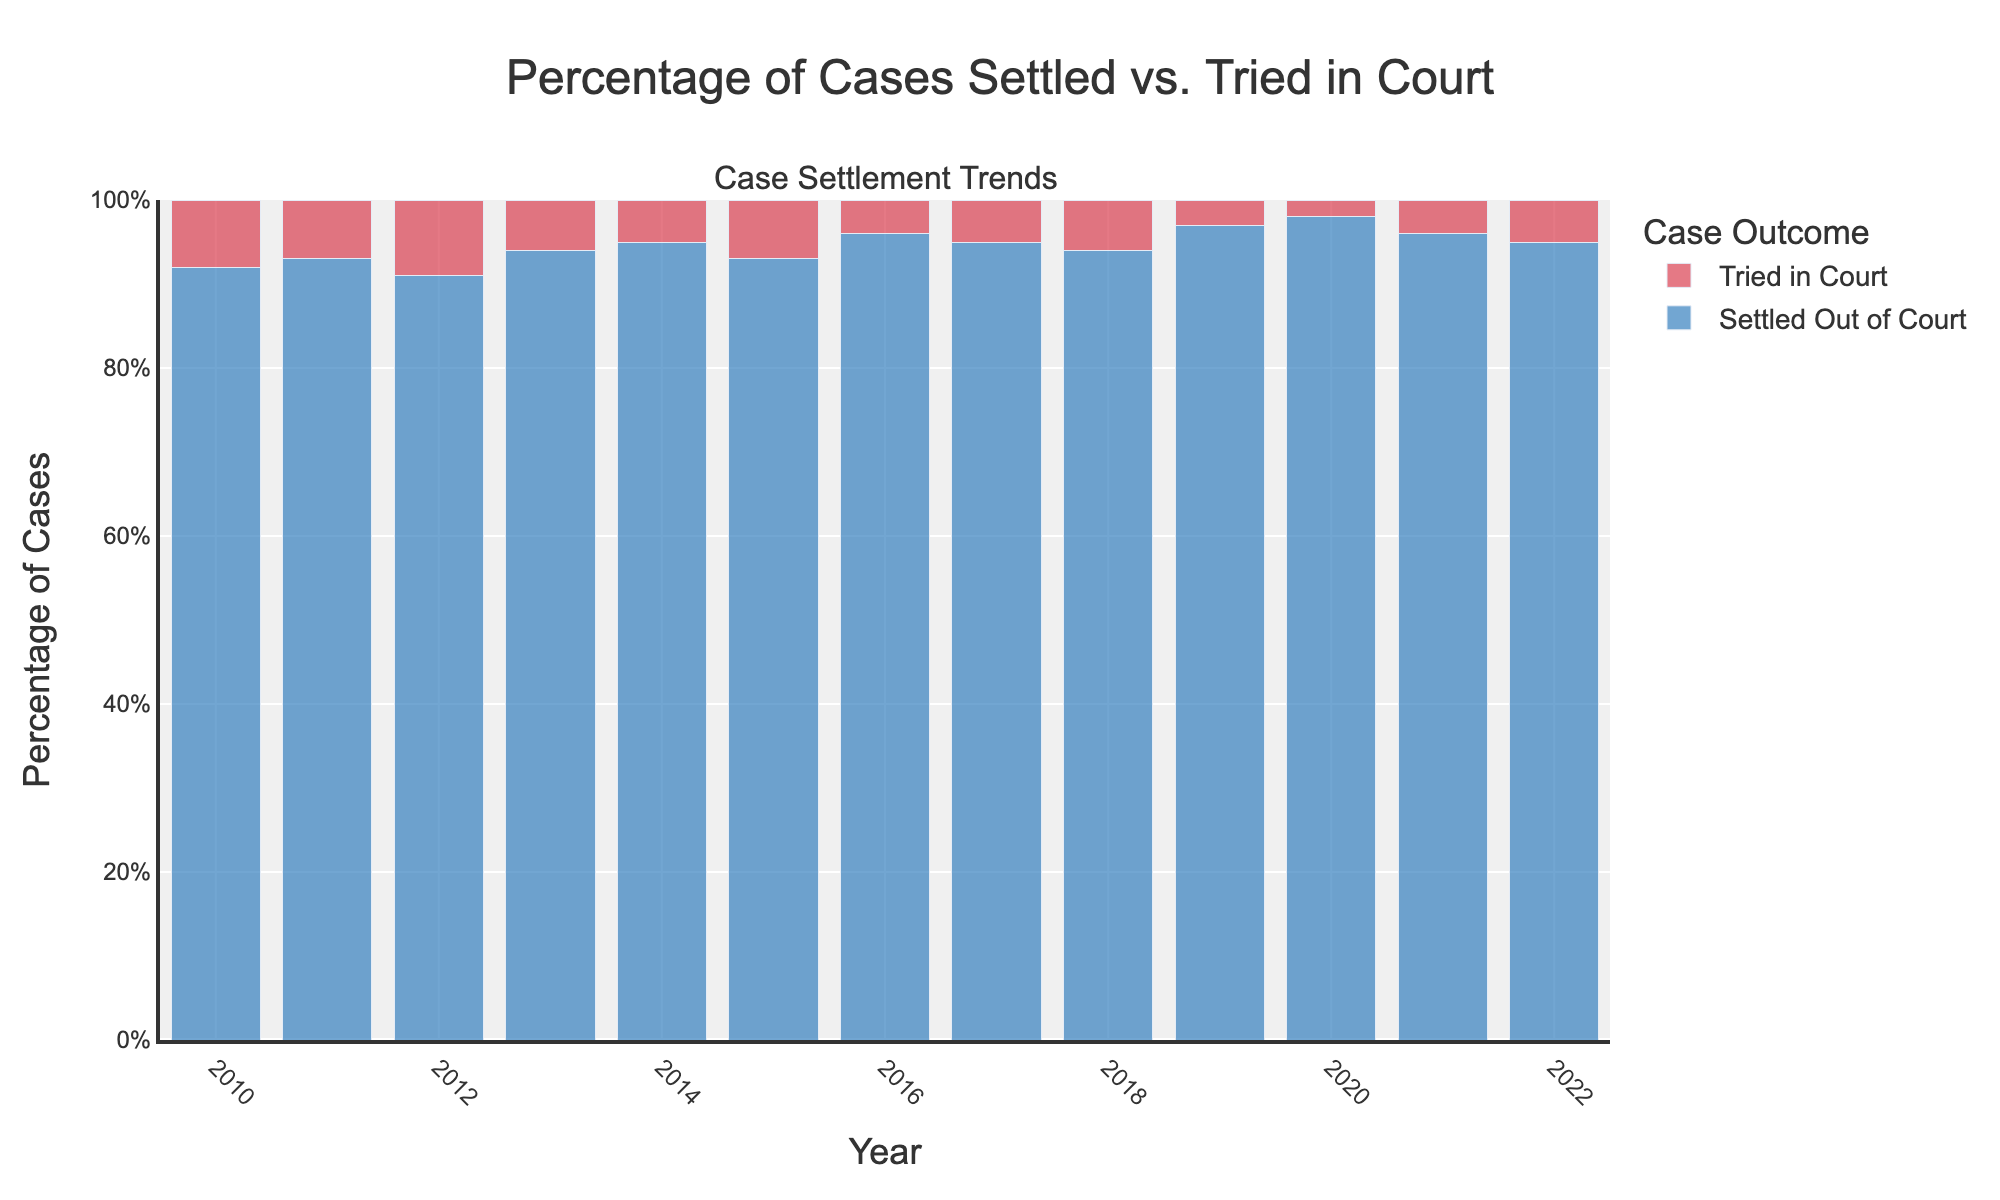Which year had the highest percentage of cases settled out of court? Look at the bar representing "Settled Out of Court" and find the tallest bar. The tallest bar corresponds to 2020.
Answer: 2020 Which year had the lowest percentage of cases tried in court? Look at the bar representing "Tried in Court" and find the shortest bar. The shortest bar corresponds to 2020.
Answer: 2020 What is the average percentage of cases settled out of court from 2010 to 2022? Sum the percentages of "Settled Out of Court" from 2010 to 2022 and divide by the number of years. (92 + 93 + 91 + 94 + 95 + 93 + 96 + 95 + 94 + 97 + 98 + 96 + 95) / 13 ≈ 94.15
Answer: 94.15 How much did the percentage of cases settled out of court increase from 2010 to 2020? Subtract the percentage of cases settled out of court in 2010 from the percentage in 2020. 98% - 92% = 6%
Answer: 6% Which year showed the greatest difference between the percentage of cases settled out of court and tried in court? Find the year where the difference between "Settled Out of Court" and "Tried in Court" percentages is the largest. The difference is maximal in 2020 (98% - 2% = 96%).
Answer: 2020 In which years did more than 95% of cases settle out of court? Identify the years where the "Settled Out of Court" percentage is greater than 95%. These years are 2016, 2019, 2020, and 2021.
Answer: 2016, 2019, 2020, 2021 How much did the percentage of cases tried in court change from 2013 to 2017? Subtract the percentage of cases tried in court in 2017 from the percentage in 2013. 5% (2017) - 6% (2013) = -1%
Answer: -1% Comparing 2015 and 2018, which year had a higher percentage of cases settled out of court and by how much? Subtract the percentage of "Settled Out of Court" in 2015 from the percentage in 2018. 94% - 93% = 1%
Answer: 2018, 1% What is the total percentage of cases tried in court over the given years? Sum the percentages of "Tried in Court" from 2010 to 2022. 8 + 7 + 9 + 6 + 5 + 7 + 4 + 5 + 6 + 3 + 2 + 4 + 5 = 71
Answer: 71 Which year had the smallest percentage difference between cases settled out of court and cases tried in court? Find the year where the absolute difference between "Settled Out of Court" and "Tried in Court" percentages is the smallest. The smallest difference is in 2012 (91% - 9% = 82%).
Answer: 2012 